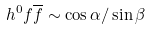Convert formula to latex. <formula><loc_0><loc_0><loc_500><loc_500>h ^ { 0 } f \overline { f } \sim \cos \alpha / \sin \beta</formula> 